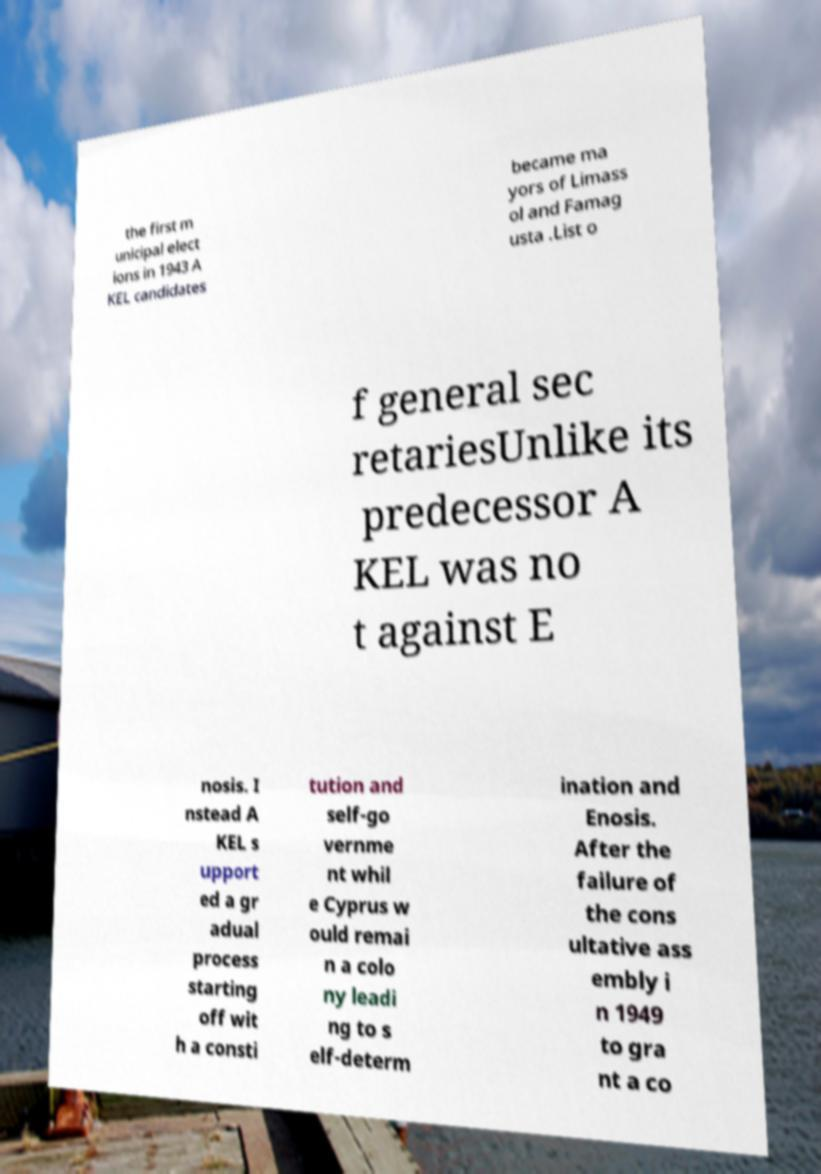There's text embedded in this image that I need extracted. Can you transcribe it verbatim? the first m unicipal elect ions in 1943 A KEL candidates became ma yors of Limass ol and Famag usta .List o f general sec retariesUnlike its predecessor A KEL was no t against E nosis. I nstead A KEL s upport ed a gr adual process starting off wit h a consti tution and self-go vernme nt whil e Cyprus w ould remai n a colo ny leadi ng to s elf-determ ination and Enosis. After the failure of the cons ultative ass embly i n 1949 to gra nt a co 